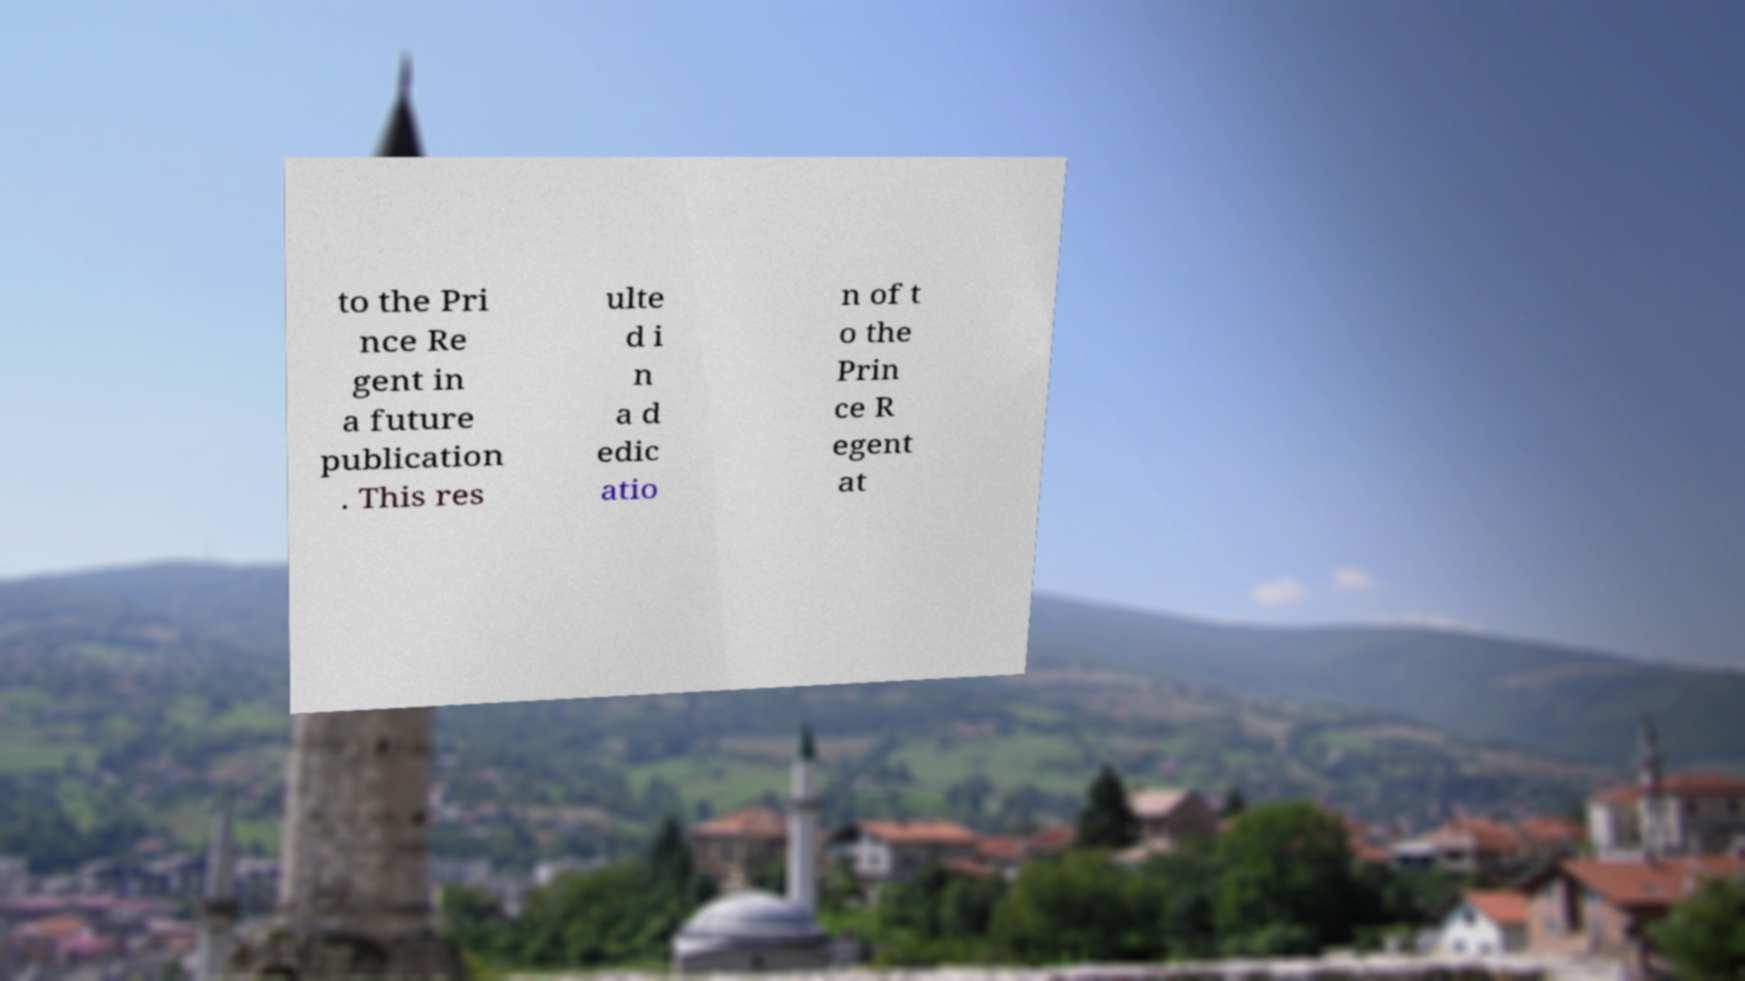Please identify and transcribe the text found in this image. to the Pri nce Re gent in a future publication . This res ulte d i n a d edic atio n of t o the Prin ce R egent at 